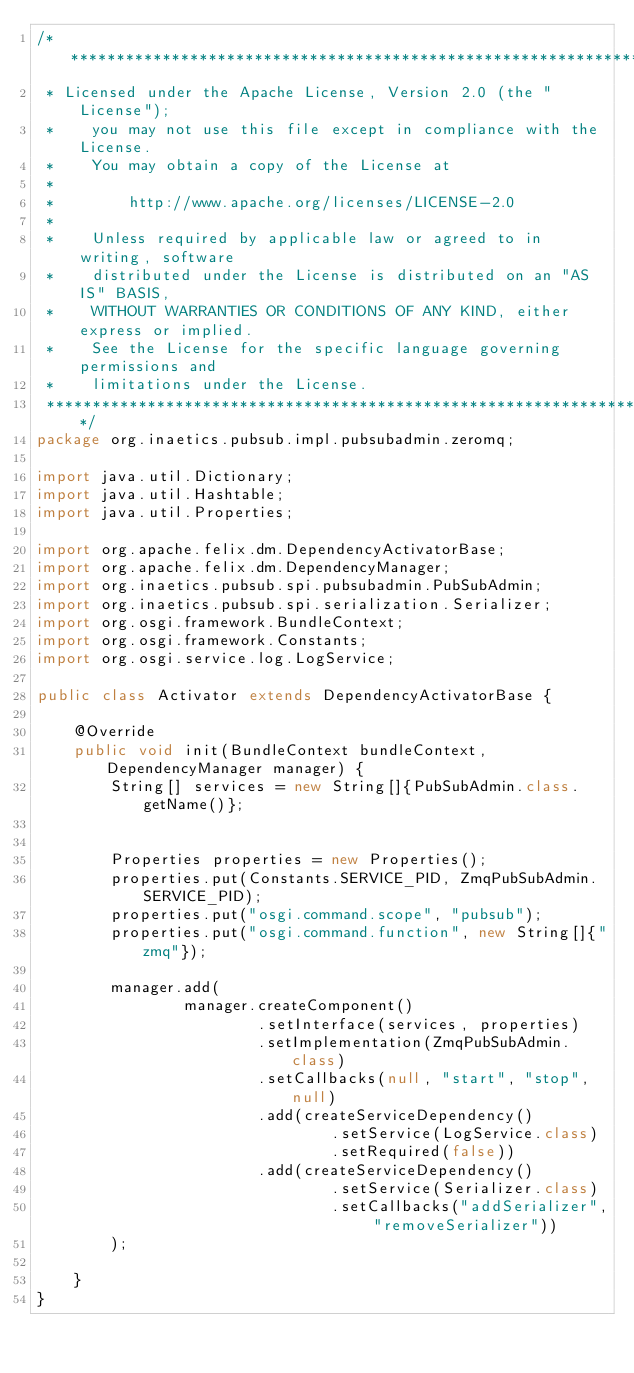<code> <loc_0><loc_0><loc_500><loc_500><_Java_>/*******************************************************************************
 * Licensed under the Apache License, Version 2.0 (the "License");
 *    you may not use this file except in compliance with the License.
 *    You may obtain a copy of the License at
 *
 *        http://www.apache.org/licenses/LICENSE-2.0
 *
 *    Unless required by applicable law or agreed to in writing, software
 *    distributed under the License is distributed on an "AS IS" BASIS,
 *    WITHOUT WARRANTIES OR CONDITIONS OF ANY KIND, either express or implied.
 *    See the License for the specific language governing permissions and
 *    limitations under the License.
 *******************************************************************************/
package org.inaetics.pubsub.impl.pubsubadmin.zeromq;

import java.util.Dictionary;
import java.util.Hashtable;
import java.util.Properties;

import org.apache.felix.dm.DependencyActivatorBase;
import org.apache.felix.dm.DependencyManager;
import org.inaetics.pubsub.spi.pubsubadmin.PubSubAdmin;
import org.inaetics.pubsub.spi.serialization.Serializer;
import org.osgi.framework.BundleContext;
import org.osgi.framework.Constants;
import org.osgi.service.log.LogService;

public class Activator extends DependencyActivatorBase {

    @Override
    public void init(BundleContext bundleContext, DependencyManager manager) {
        String[] services = new String[]{PubSubAdmin.class.getName()};


        Properties properties = new Properties();
        properties.put(Constants.SERVICE_PID, ZmqPubSubAdmin.SERVICE_PID);
        properties.put("osgi.command.scope", "pubsub");
        properties.put("osgi.command.function", new String[]{"zmq"});

        manager.add(
                manager.createComponent()
                        .setInterface(services, properties)
                        .setImplementation(ZmqPubSubAdmin.class)
                        .setCallbacks(null, "start", "stop", null)
                        .add(createServiceDependency()
                                .setService(LogService.class)
                                .setRequired(false))
                        .add(createServiceDependency()
                                .setService(Serializer.class)
                                .setCallbacks("addSerializer", "removeSerializer"))
        );

    }
}
</code> 